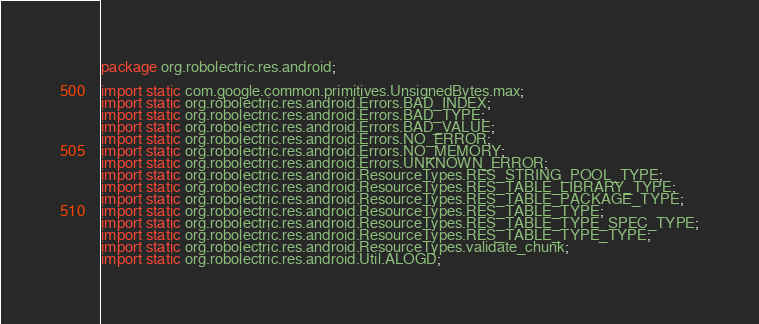<code> <loc_0><loc_0><loc_500><loc_500><_Java_>package org.robolectric.res.android;

import static com.google.common.primitives.UnsignedBytes.max;
import static org.robolectric.res.android.Errors.BAD_INDEX;
import static org.robolectric.res.android.Errors.BAD_TYPE;
import static org.robolectric.res.android.Errors.BAD_VALUE;
import static org.robolectric.res.android.Errors.NO_ERROR;
import static org.robolectric.res.android.Errors.NO_MEMORY;
import static org.robolectric.res.android.Errors.UNKNOWN_ERROR;
import static org.robolectric.res.android.ResourceTypes.RES_STRING_POOL_TYPE;
import static org.robolectric.res.android.ResourceTypes.RES_TABLE_LIBRARY_TYPE;
import static org.robolectric.res.android.ResourceTypes.RES_TABLE_PACKAGE_TYPE;
import static org.robolectric.res.android.ResourceTypes.RES_TABLE_TYPE;
import static org.robolectric.res.android.ResourceTypes.RES_TABLE_TYPE_SPEC_TYPE;
import static org.robolectric.res.android.ResourceTypes.RES_TABLE_TYPE_TYPE;
import static org.robolectric.res.android.ResourceTypes.validate_chunk;
import static org.robolectric.res.android.Util.ALOGD;</code> 